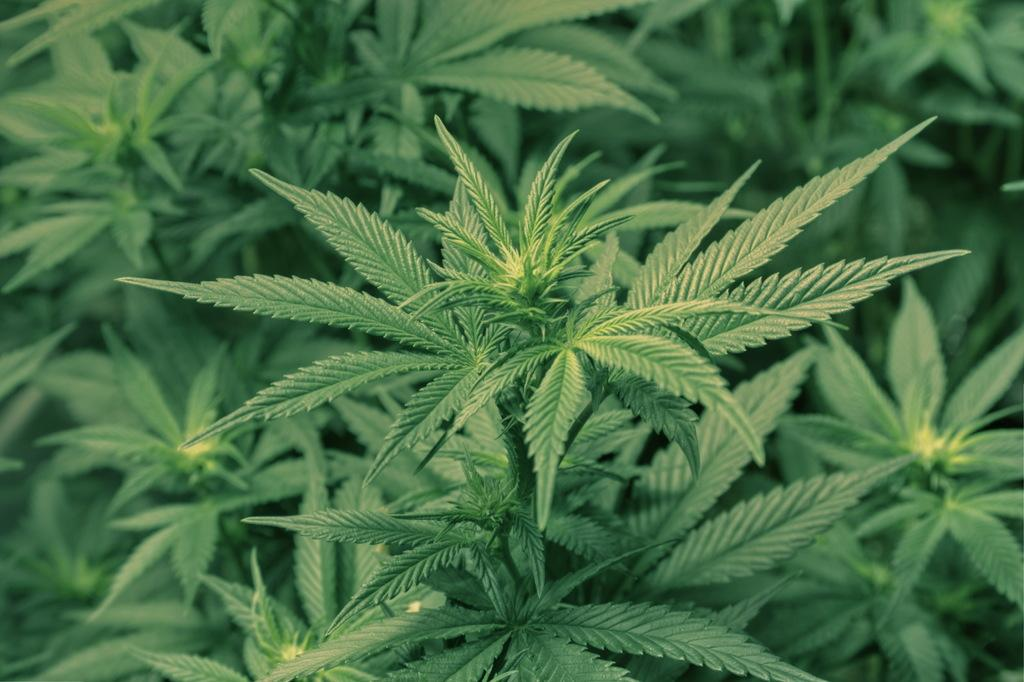What type of living organisms can be seen in the image? Plants can be seen in the image. How many horses are playing chess in the image? There are no horses or chess games present in the image; it features plants. 